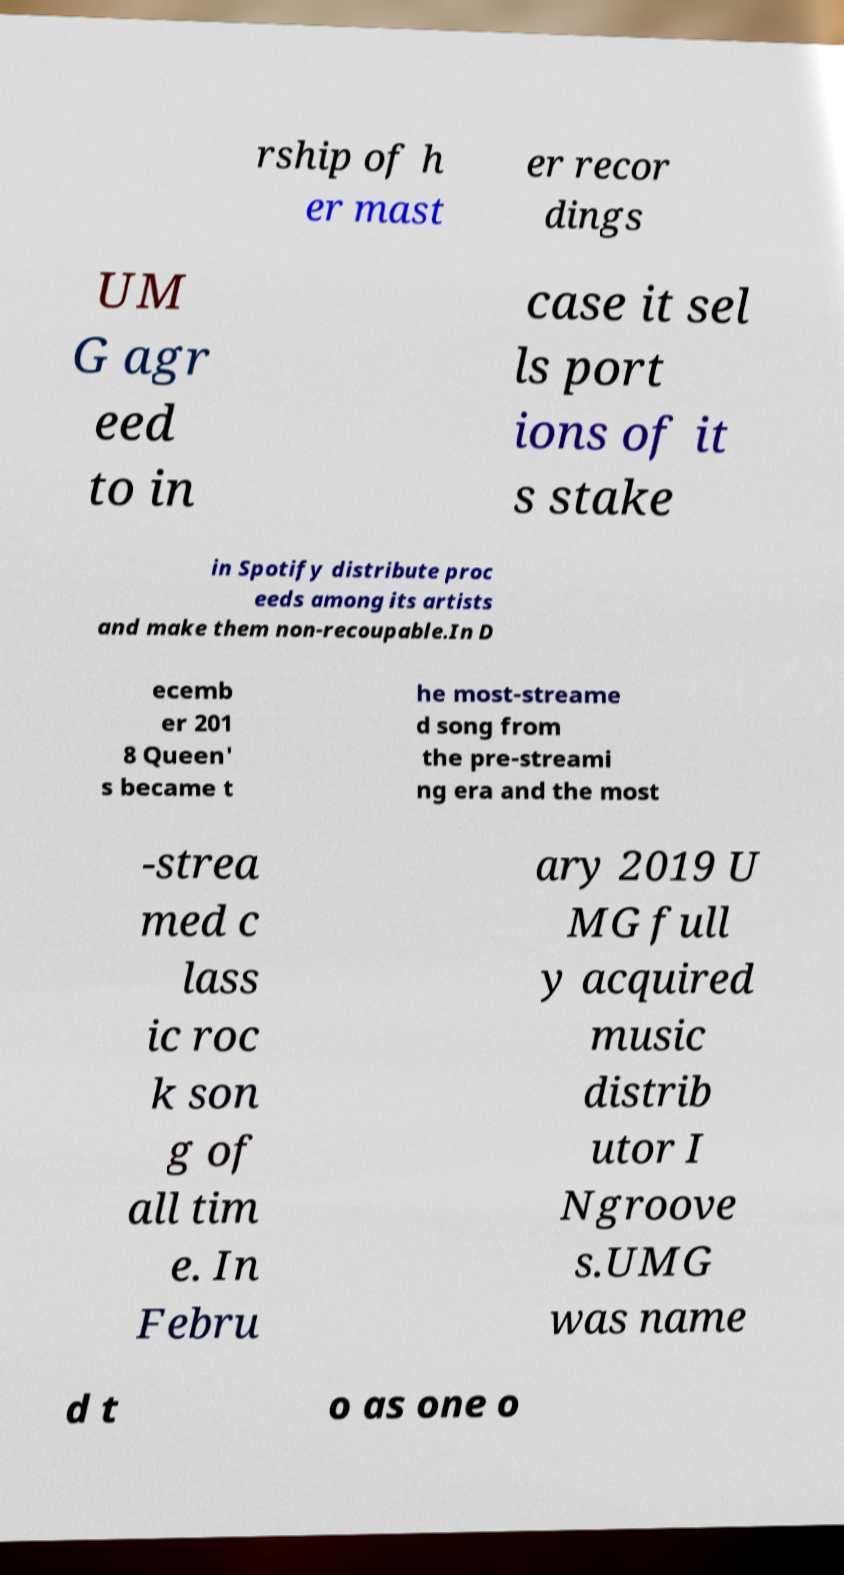Could you extract and type out the text from this image? rship of h er mast er recor dings UM G agr eed to in case it sel ls port ions of it s stake in Spotify distribute proc eeds among its artists and make them non-recoupable.In D ecemb er 201 8 Queen' s became t he most-streame d song from the pre-streami ng era and the most -strea med c lass ic roc k son g of all tim e. In Febru ary 2019 U MG full y acquired music distrib utor I Ngroove s.UMG was name d t o as one o 